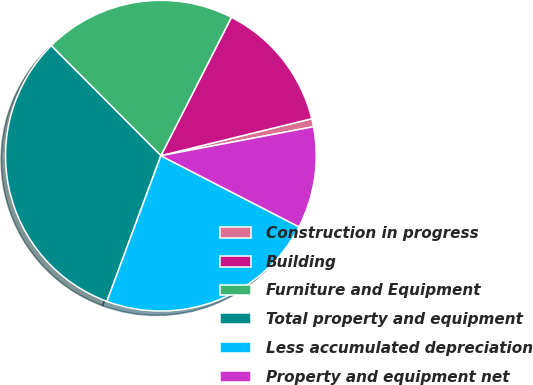Convert chart to OTSL. <chart><loc_0><loc_0><loc_500><loc_500><pie_chart><fcel>Construction in progress<fcel>Building<fcel>Furniture and Equipment<fcel>Total property and equipment<fcel>Less accumulated depreciation<fcel>Property and equipment net<nl><fcel>0.84%<fcel>13.67%<fcel>19.97%<fcel>31.88%<fcel>23.07%<fcel>10.56%<nl></chart> 